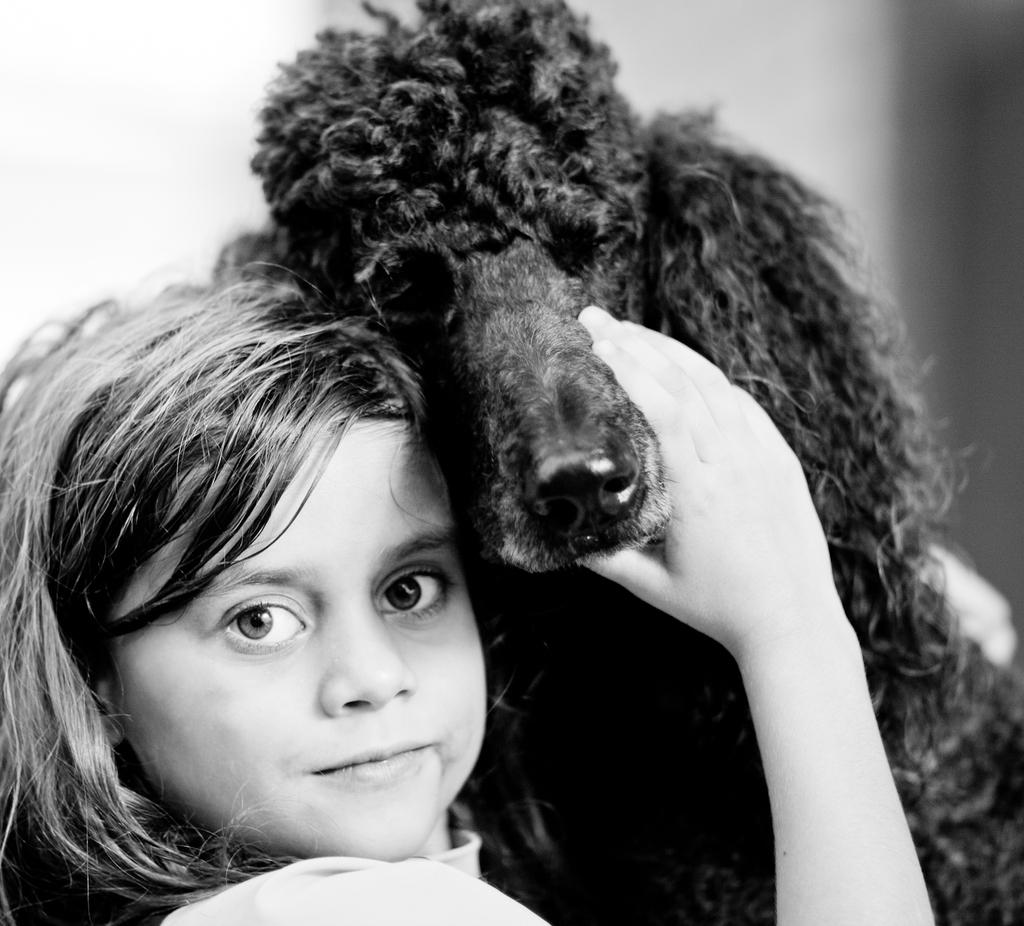What is the color scheme of the image? The image is black and white. Who is present in the image? There is a girl in the image. What is the girl doing in the image? The girl is smiling in the image. What is the girl holding in the image? The girl is holding a dog in the image. What type of bulb can be seen in the image? There is no bulb present in the image. What kind of machine is the girl operating in the image? There is no machine present in the image. 